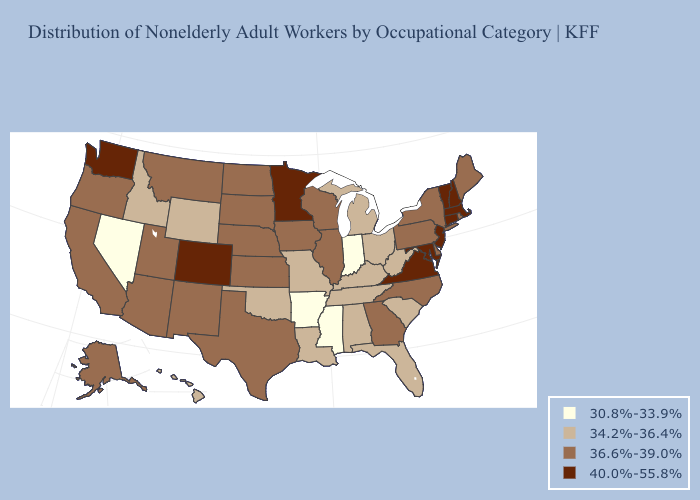Among the states that border Virginia , does West Virginia have the lowest value?
Keep it brief. Yes. Which states have the highest value in the USA?
Write a very short answer. Colorado, Connecticut, Maryland, Massachusetts, Minnesota, New Hampshire, New Jersey, Vermont, Virginia, Washington. Name the states that have a value in the range 36.6%-39.0%?
Keep it brief. Alaska, Arizona, California, Delaware, Georgia, Illinois, Iowa, Kansas, Maine, Montana, Nebraska, New Mexico, New York, North Carolina, North Dakota, Oregon, Pennsylvania, Rhode Island, South Dakota, Texas, Utah, Wisconsin. What is the highest value in the USA?
Short answer required. 40.0%-55.8%. Does Arkansas have the lowest value in the South?
Answer briefly. Yes. What is the highest value in the USA?
Short answer required. 40.0%-55.8%. Name the states that have a value in the range 36.6%-39.0%?
Short answer required. Alaska, Arizona, California, Delaware, Georgia, Illinois, Iowa, Kansas, Maine, Montana, Nebraska, New Mexico, New York, North Carolina, North Dakota, Oregon, Pennsylvania, Rhode Island, South Dakota, Texas, Utah, Wisconsin. Which states have the highest value in the USA?
Short answer required. Colorado, Connecticut, Maryland, Massachusetts, Minnesota, New Hampshire, New Jersey, Vermont, Virginia, Washington. Name the states that have a value in the range 34.2%-36.4%?
Concise answer only. Alabama, Florida, Hawaii, Idaho, Kentucky, Louisiana, Michigan, Missouri, Ohio, Oklahoma, South Carolina, Tennessee, West Virginia, Wyoming. Name the states that have a value in the range 34.2%-36.4%?
Give a very brief answer. Alabama, Florida, Hawaii, Idaho, Kentucky, Louisiana, Michigan, Missouri, Ohio, Oklahoma, South Carolina, Tennessee, West Virginia, Wyoming. Does Nevada have the lowest value in the West?
Concise answer only. Yes. What is the value of West Virginia?
Write a very short answer. 34.2%-36.4%. Name the states that have a value in the range 30.8%-33.9%?
Write a very short answer. Arkansas, Indiana, Mississippi, Nevada. Name the states that have a value in the range 36.6%-39.0%?
Short answer required. Alaska, Arizona, California, Delaware, Georgia, Illinois, Iowa, Kansas, Maine, Montana, Nebraska, New Mexico, New York, North Carolina, North Dakota, Oregon, Pennsylvania, Rhode Island, South Dakota, Texas, Utah, Wisconsin. Does Colorado have the highest value in the West?
Short answer required. Yes. 